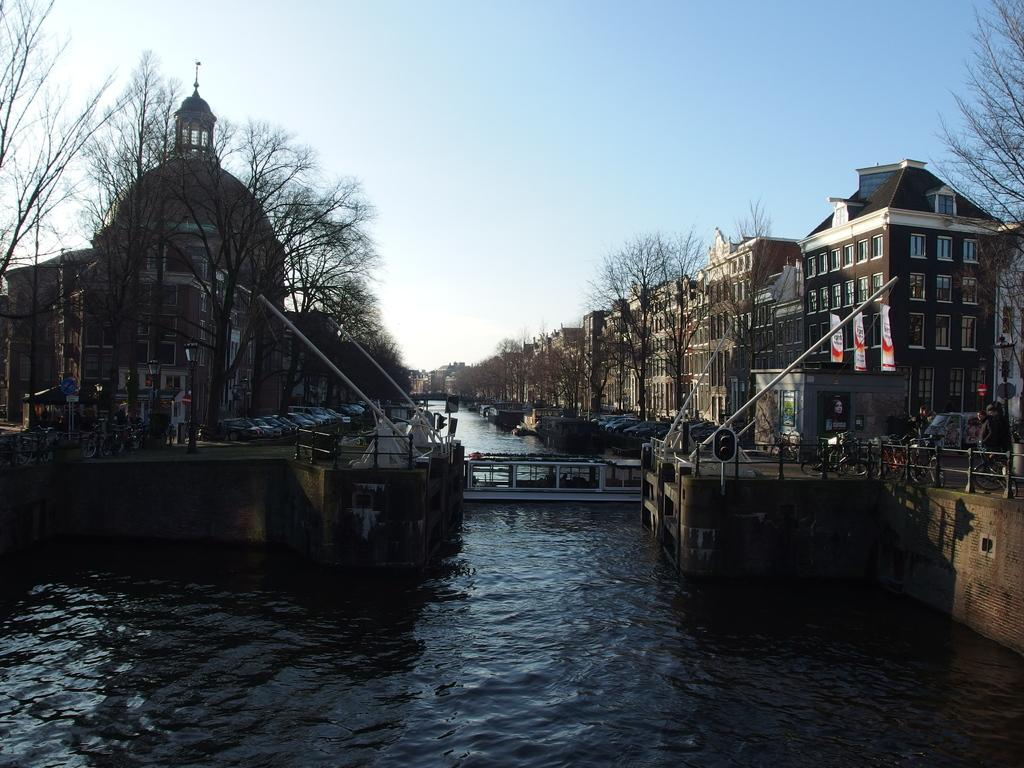What natural feature is present in the image? There is a river in the image. What structure crosses the river? There is a bridge across the river. What types of vehicles can be seen in the image? There are vehicles on either side of the river. What type of man-made structures are present on either side of the river? There are buildings on either side of the river. What type of vegetation is present on either side of the river? There are trees on either side of the river. What type of drum can be seen being played in the image? There is no drum present in the image. Where is the store located in the image? There is no store present in the image. 